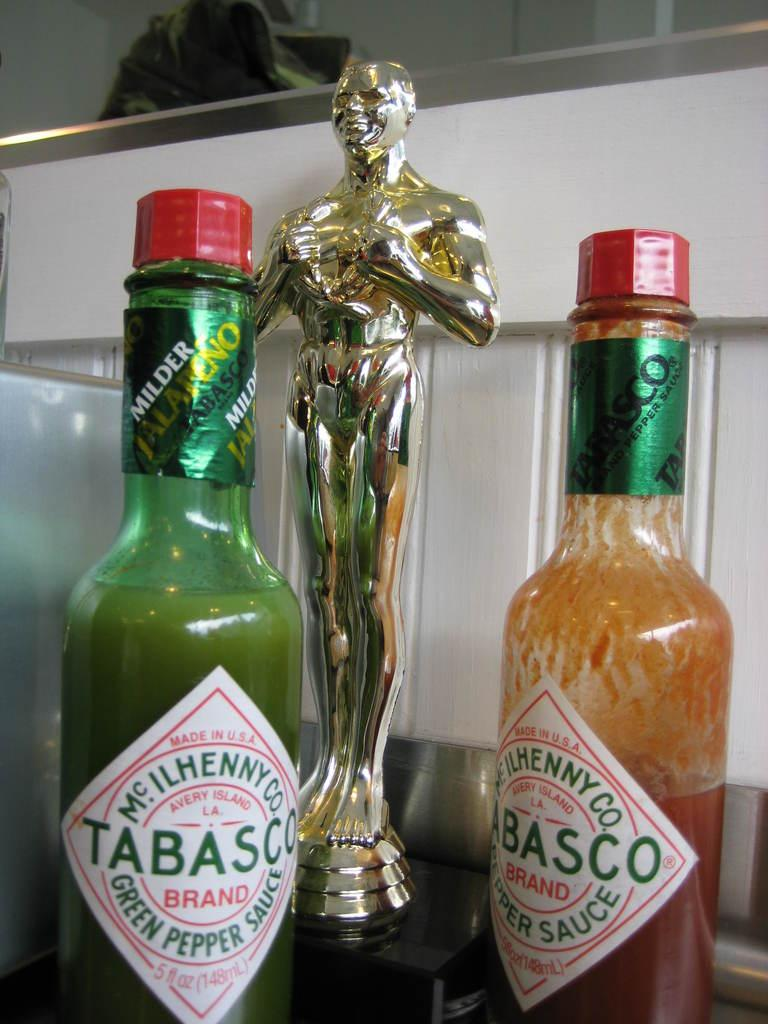<image>
Create a compact narrative representing the image presented. A green jar of Tabasco sits next to a trophy 